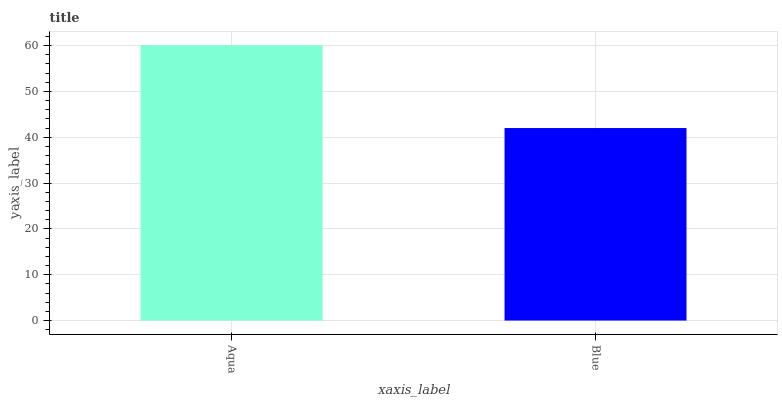Is Blue the minimum?
Answer yes or no. Yes. Is Aqua the maximum?
Answer yes or no. Yes. Is Blue the maximum?
Answer yes or no. No. Is Aqua greater than Blue?
Answer yes or no. Yes. Is Blue less than Aqua?
Answer yes or no. Yes. Is Blue greater than Aqua?
Answer yes or no. No. Is Aqua less than Blue?
Answer yes or no. No. Is Aqua the high median?
Answer yes or no. Yes. Is Blue the low median?
Answer yes or no. Yes. Is Blue the high median?
Answer yes or no. No. Is Aqua the low median?
Answer yes or no. No. 